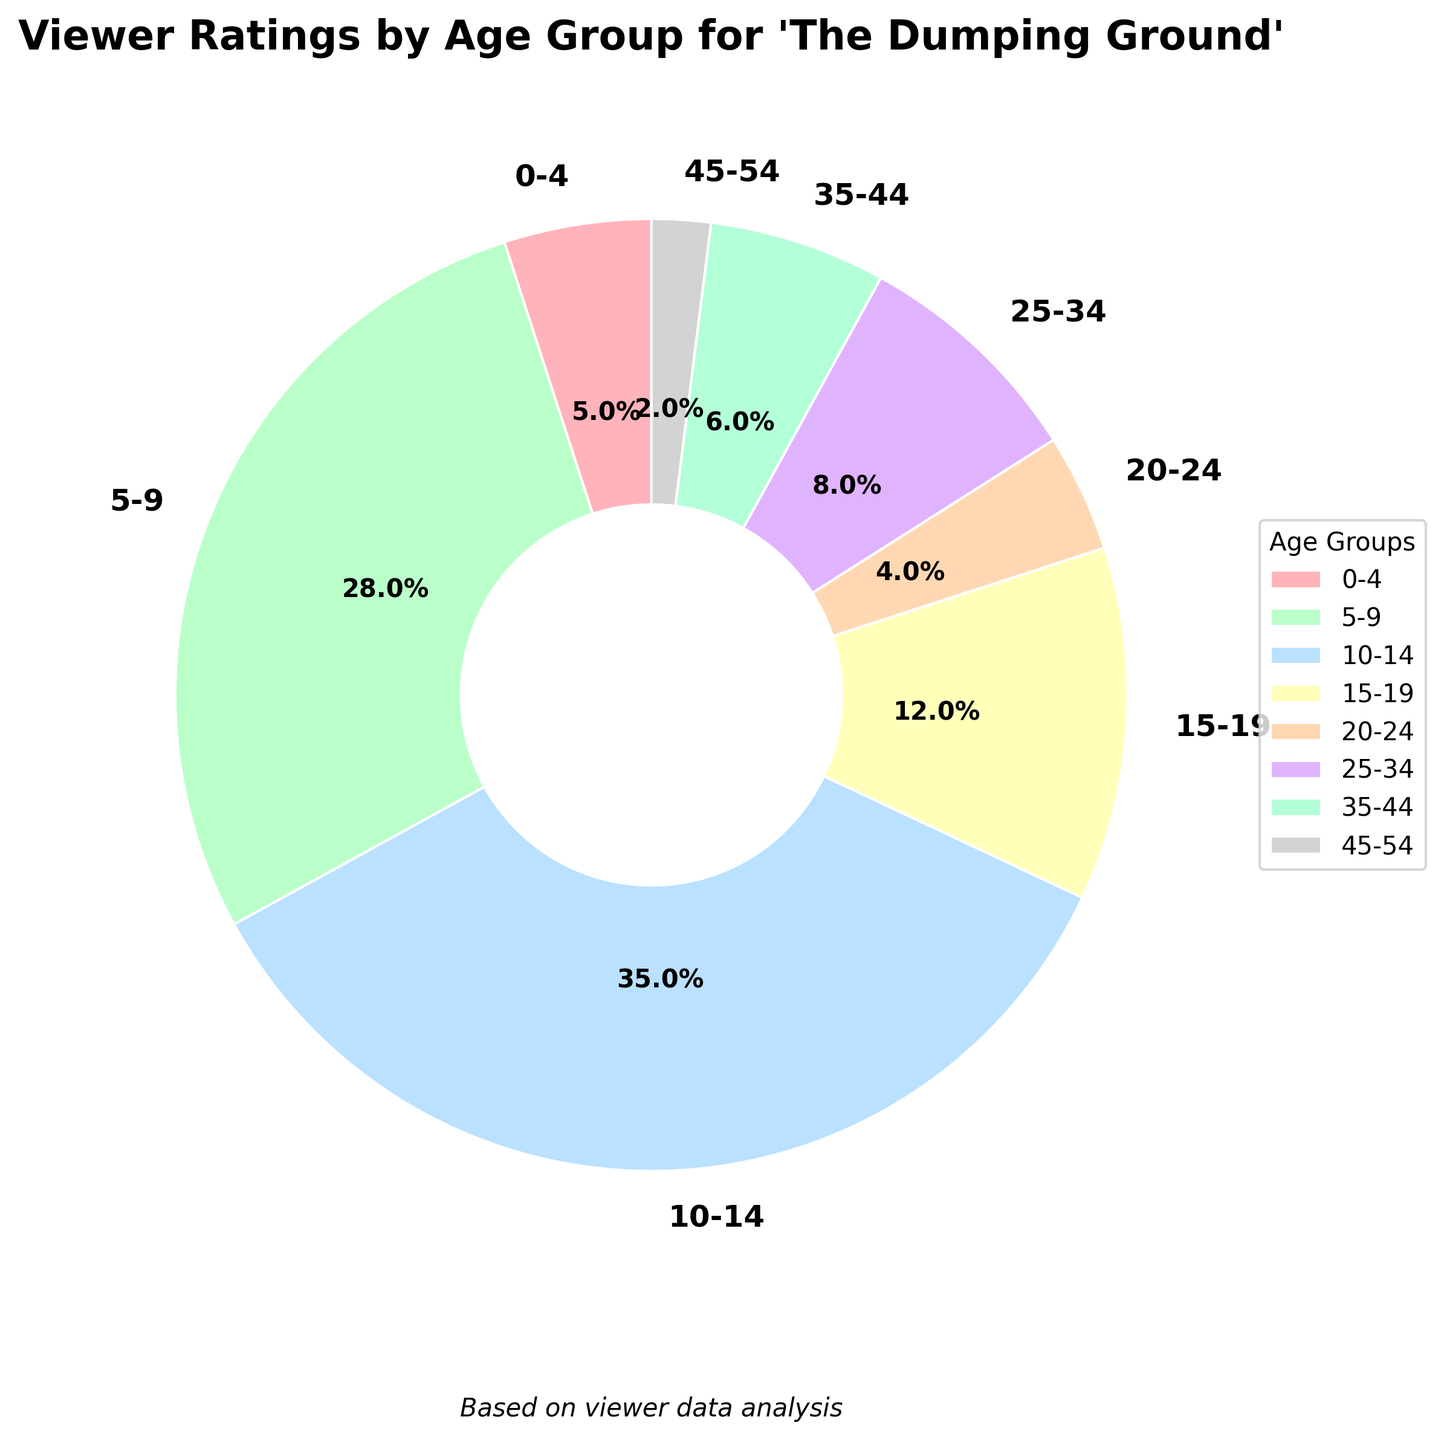Which age group has the highest percentage of viewers? The figure shows a pie chart with each segment labeled by age group and percentage. The largest segment corresponds to the 10-14 age group with 35%.
Answer: 10-14 Which age groups have a combined viewer percentage greater than 50%? By looking at the chart, the segments for ages 5-9 (28%), 10-14 (35%), and 15-19 (12%) add up to 75%, which is greater than 50%.
Answer: 5-9, 10-14, 15-19 How much higher is the percentage of viewers aged 10-14 compared to those aged 5-9? The percentage for the 10-14 group is 35%, and the percentage for the 5-9 group is 28%. The difference is calculated as 35% - 28%.
Answer: 7% Which age group has the smallest percentage of viewers? The figure shows that the age group 45-54 has the smallest segment, labeled with 2%.
Answer: 45-54 What is the total percentage of viewers aged 20 and above? Adding the percentages for the age groups 20-24, 25-34, 35-44, and 45-54: 4% + 8% + 6% + 2% = 20%.
Answer: 20% Which color represents the age group 0-4? The figure segments are color-coded, and the segment for the age group 0-4 is pinkish (#FFB3BA as per code).
Answer: Pink Is there a significant difference in the percentage of viewers aged 15-19 and 0-4? The percentage of the 15-19 group is 12% and the 0-4 group is 5%. The difference is calculated as 12% - 5%.
Answer: 7% Which age group has a viewer percentage closest to 10%? The age group 15-19 has a percentage of 12%, and the age group 0-4 has 5%. The closest to 10% is 15-19.
Answer: 15-19 